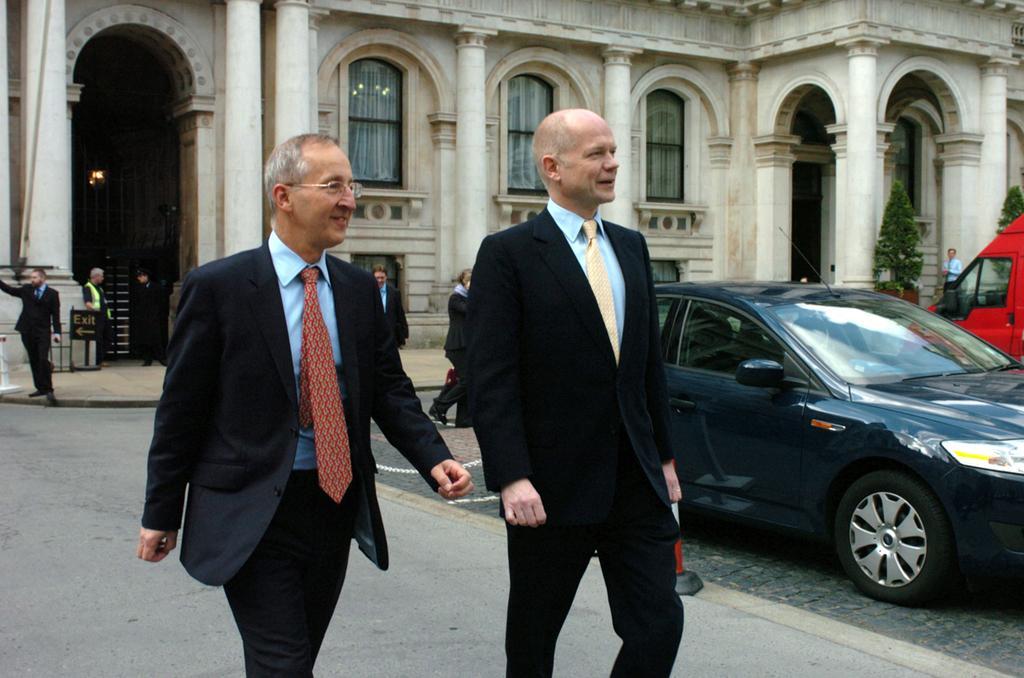Please provide a concise description of this image. There are two men walking and smiling. This is a car, which is parked. I can see a building with the windows and pillars. There are few people standing. This looks like an exit board. I can see the trees. On the right corner of the image, I can see another vehicle, which is red in color. 